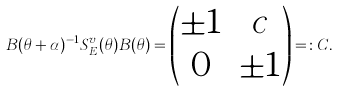Convert formula to latex. <formula><loc_0><loc_0><loc_500><loc_500>B ( \theta + \alpha ) ^ { - 1 } S _ { E } ^ { v } ( \theta ) B ( \theta ) = \begin{pmatrix} \pm 1 & c \\ 0 & \pm 1 \end{pmatrix} = \colon C .</formula> 